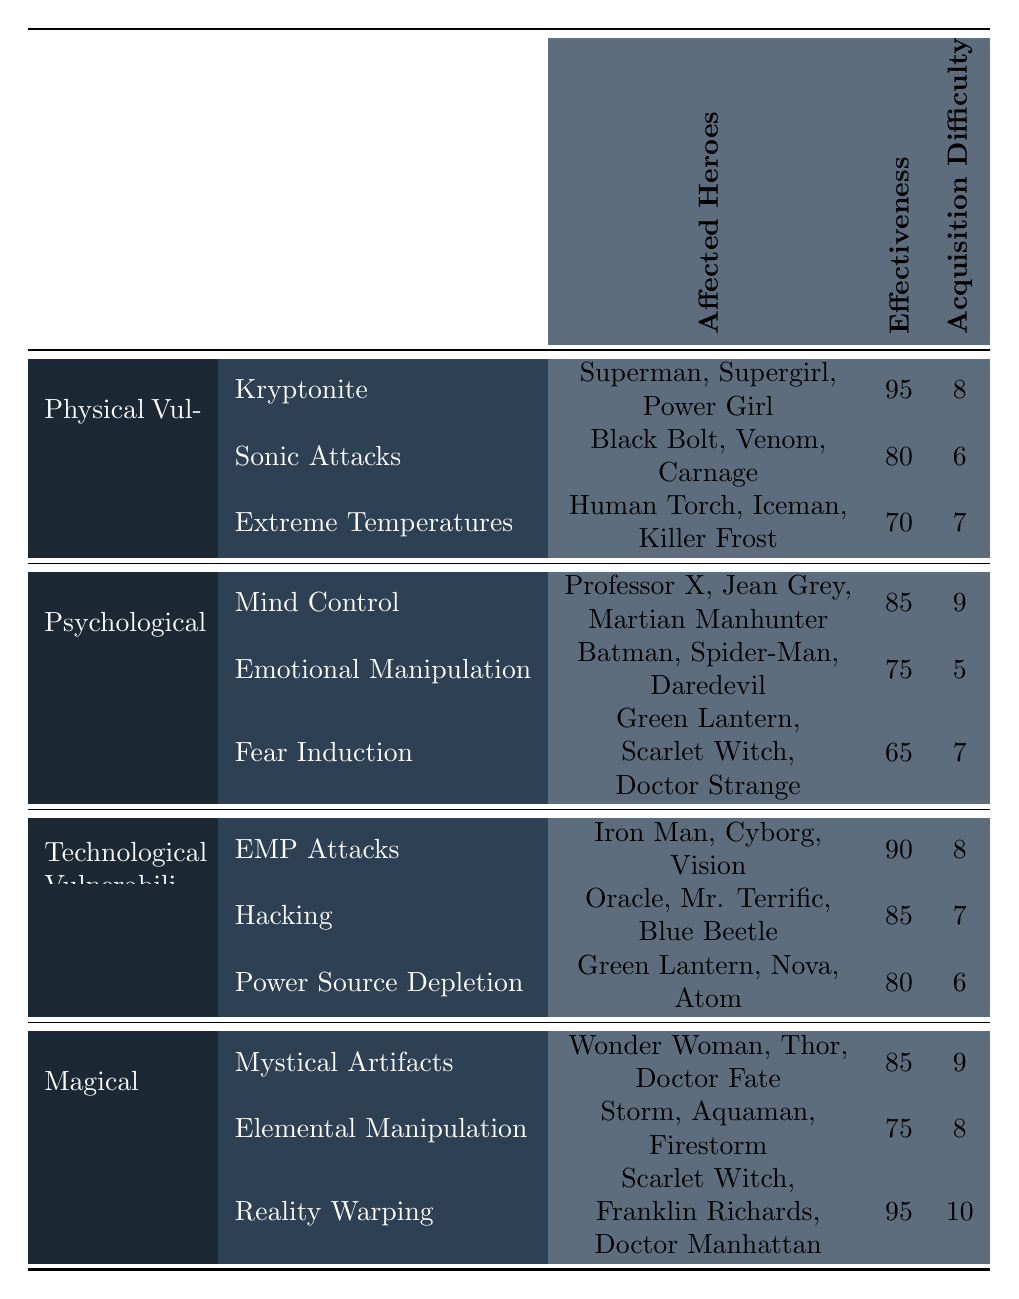What is the effectiveness of Kryptonite against superhero vulnerabilities? The table shows that the effectiveness of Kryptonite is listed as 95.
Answer: 95 Which category has the highest average acquisition difficulty? To find the average acquisition difficulty for each category, we sum the difficulty values for each subcategory and divide by the number of subcategories. For Physical Vulnerabilities: (8 + 6 + 7) / 3 = 7. For Psychological Weaknesses: (9 + 5 + 7) / 3 = 7. For Technological Vulnerabilities: (8 + 7 + 6) / 3 = 7. For Magical Weaknesses: (9 + 8 + 10) / 3 = 9. Thus, Magical Weaknesses has the highest average acquisition difficulty of 9.
Answer: Magical Weaknesses Are there any superheroes affected by both Sonic Attacks and Emotional Manipulation? By examining the affected heroes for each weakness, we find that there are no overlap or shared heroes cited under Sonic Attacks (Black Bolt, Venom, Carnage) and Emotional Manipulation (Batman, Spider-Man, Daredevil). Hence, there are no superheroes affected by both.
Answer: No What is the total effectiveness of all psychological weaknesses combined, and how does it compare to the total effectiveness of physical vulnerabilities? The total effectiveness of psychological weaknesses is calculated as follows: 85 (Mind Control) + 75 (Emotional Manipulation) + 65 (Fear Induction) = 225. For physical vulnerabilities: 95 (Kryptonite) + 80 (Sonic Attacks) + 70 (Extreme Temperatures) = 245. Thus, the psychological weaknesses total is less than that of physical vulnerabilities.
Answer: Psychological weaknesses total 225; physical vulnerabilities total 245 Which superhero has the highest effectiveness of vulnerability according to the table? The analysis reveals that Reality Warping affects superheroes (Scarlet Witch, Franklin Richards, Doctor Manhattan) with an effectiveness of 95, which is the highest recorded in the table.
Answer: 95 (Reality Warping) How many heroes are affected by Extreme Temperatures, and how does this compare to the number of heroes affected by Hacking? Extreme Temperatures affects 3 heroes (Human Torch, Iceman, Killer Frost) and Hacking affects 3 heroes (Oracle, Mr. Terrific, Blue Beetle), thus they both affect the same number of heroes.
Answer: Both affect 3 heroes Is there any form of weakness that affects the same number of heroes as Elemental Manipulation? Elemental Manipulation also affects 3 heroes (Storm, Aquaman, Firestorm), and we see that both Extreme Temperatures and Hacking also affect 3 heroes. Therefore, there are forms of weakness that affect the same number of heroes.
Answer: Yes, both Extreme Temperatures and Hacking also affect 3 heroes What is the total acquisition difficulty if we sum all types of weaknesses in the table? Adding all acquisition difficulties together gives: 8 (Kryptonite) + 6 (Sonic Attacks) + 7 (Extreme Temperatures) + 9 (Mind Control) + 5 (Emotional Manipulation) + 7 (Fear Induction) + 8 (EMP Attacks) + 7 (Hacking) + 6 (Power Source Depletion) + 9 (Mystical Artifacts) + 8 (Elemental Manipulation) + 10 (Reality Warping) = 81.
Answer: 81 